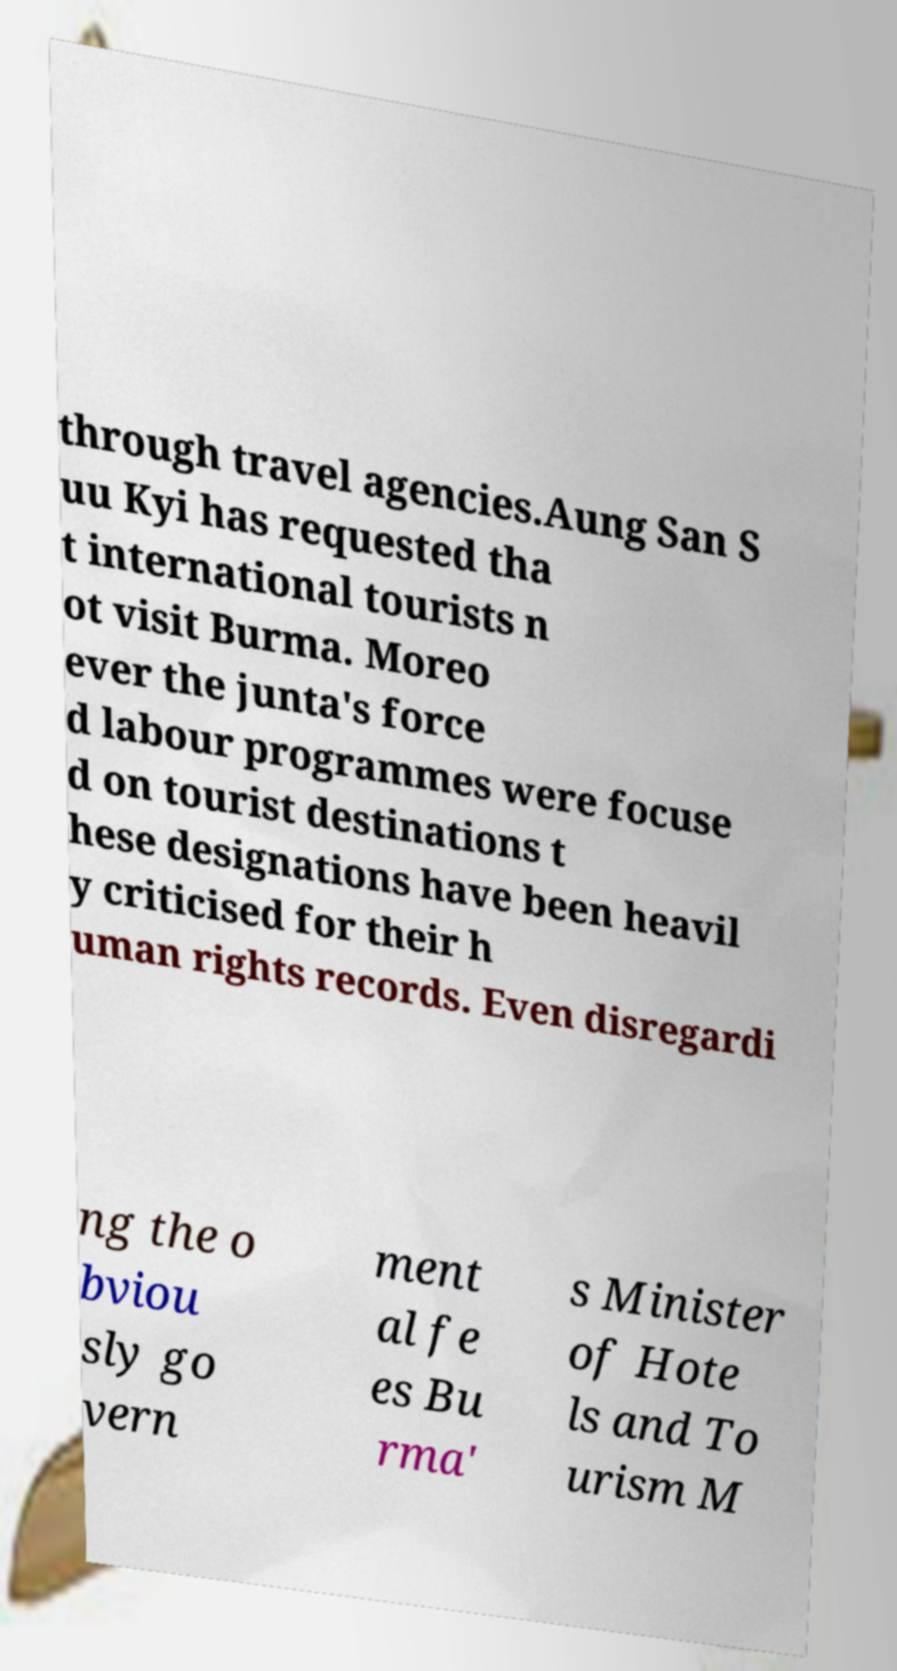Can you read and provide the text displayed in the image?This photo seems to have some interesting text. Can you extract and type it out for me? through travel agencies.Aung San S uu Kyi has requested tha t international tourists n ot visit Burma. Moreo ever the junta's force d labour programmes were focuse d on tourist destinations t hese designations have been heavil y criticised for their h uman rights records. Even disregardi ng the o bviou sly go vern ment al fe es Bu rma' s Minister of Hote ls and To urism M 